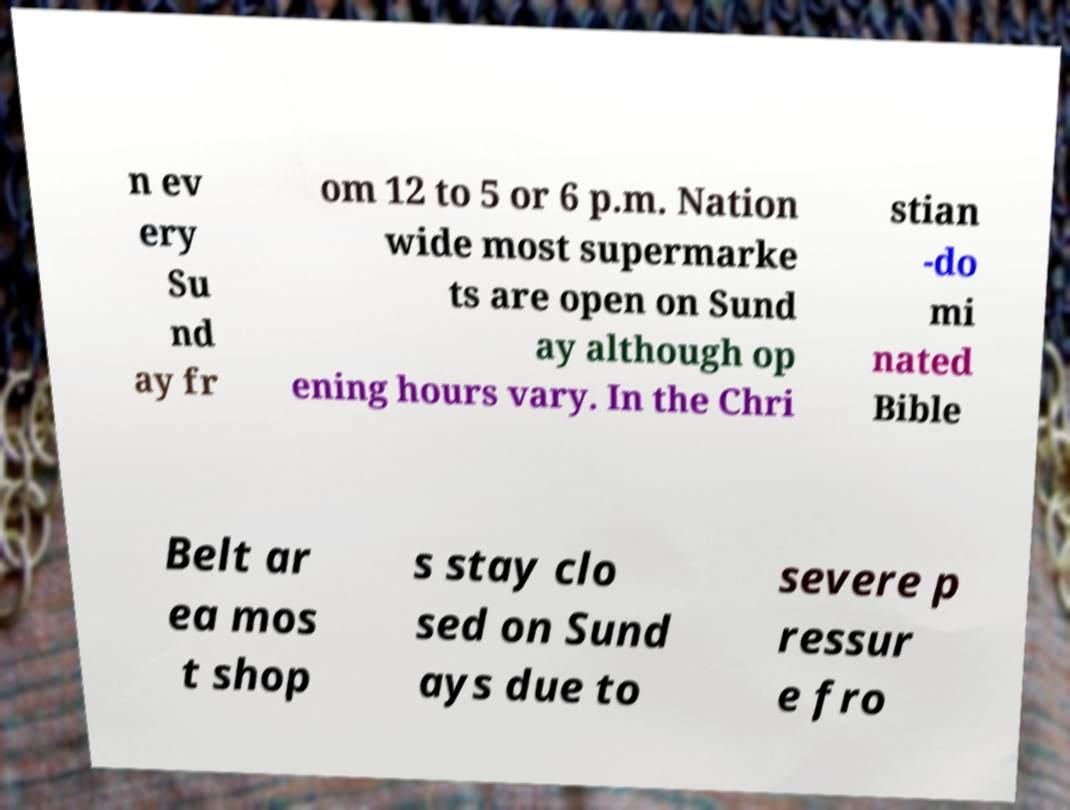Please read and relay the text visible in this image. What does it say? n ev ery Su nd ay fr om 12 to 5 or 6 p.m. Nation wide most supermarke ts are open on Sund ay although op ening hours vary. In the Chri stian -do mi nated Bible Belt ar ea mos t shop s stay clo sed on Sund ays due to severe p ressur e fro 